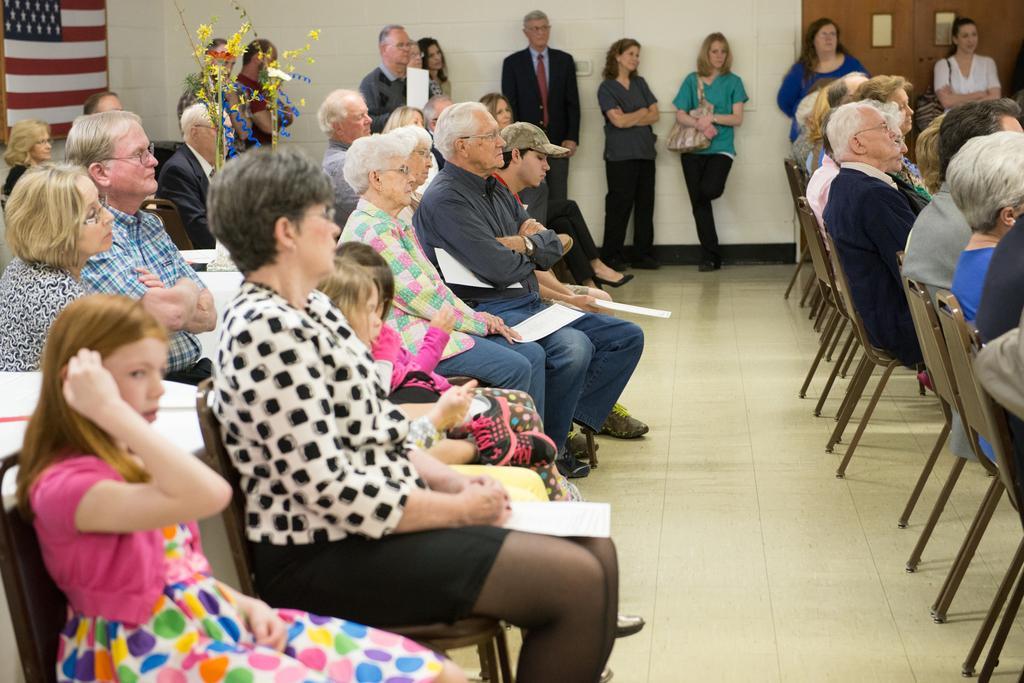Can you describe this image briefly? In the image there are many people sat on chair and some people stood near the wall ,in the background there is american flag. 